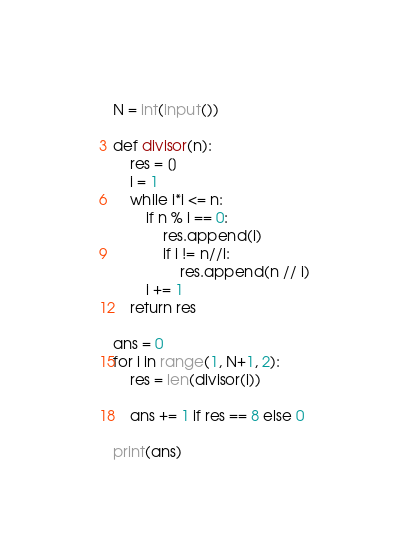Convert code to text. <code><loc_0><loc_0><loc_500><loc_500><_Python_>N = int(input())

def divisor(n):
    res = []
    i = 1
    while i*i <= n:
        if n % i == 0:
            res.append(i)
            if i != n//i:
                res.append(n // i)
        i += 1
    return res

ans = 0
for i in range(1, N+1, 2):
    res = len(divisor(i))

    ans += 1 if res == 8 else 0

print(ans)
</code> 